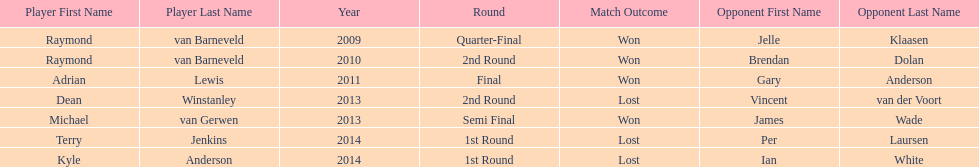Did terry jenkins or per laursen win in 2014? Per Laursen. 